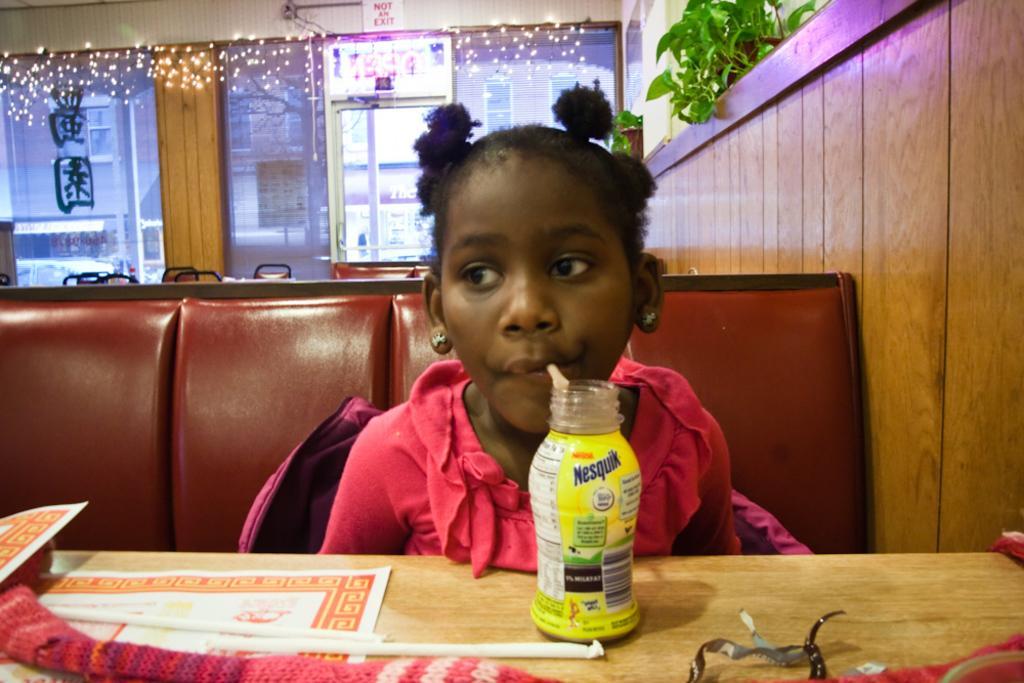Can you describe this image briefly? In this image I see a girl who is wearing a pink dress and she is sitting on a couch, I can also see there is a table in front of her on which there are straws, a bottle in which there is another straw and that straw is in the girl's mouth. In the background I see the wall, lights over here and I see the plants. 